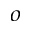<formula> <loc_0><loc_0><loc_500><loc_500>^ { o }</formula> 